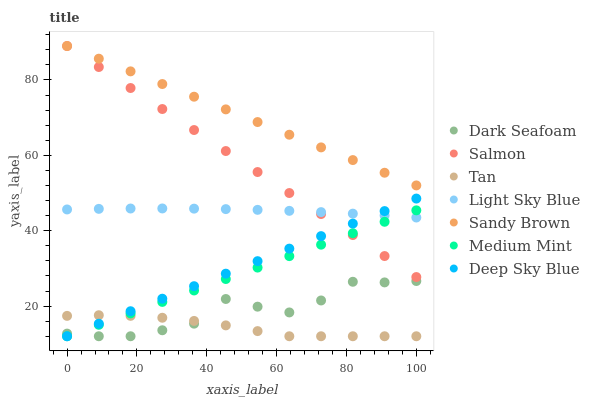Does Tan have the minimum area under the curve?
Answer yes or no. Yes. Does Sandy Brown have the maximum area under the curve?
Answer yes or no. Yes. Does Salmon have the minimum area under the curve?
Answer yes or no. No. Does Salmon have the maximum area under the curve?
Answer yes or no. No. Is Deep Sky Blue the smoothest?
Answer yes or no. Yes. Is Dark Seafoam the roughest?
Answer yes or no. Yes. Is Salmon the smoothest?
Answer yes or no. No. Is Salmon the roughest?
Answer yes or no. No. Does Medium Mint have the lowest value?
Answer yes or no. Yes. Does Salmon have the lowest value?
Answer yes or no. No. Does Sandy Brown have the highest value?
Answer yes or no. Yes. Does Dark Seafoam have the highest value?
Answer yes or no. No. Is Deep Sky Blue less than Sandy Brown?
Answer yes or no. Yes. Is Salmon greater than Tan?
Answer yes or no. Yes. Does Salmon intersect Deep Sky Blue?
Answer yes or no. Yes. Is Salmon less than Deep Sky Blue?
Answer yes or no. No. Is Salmon greater than Deep Sky Blue?
Answer yes or no. No. Does Deep Sky Blue intersect Sandy Brown?
Answer yes or no. No. 